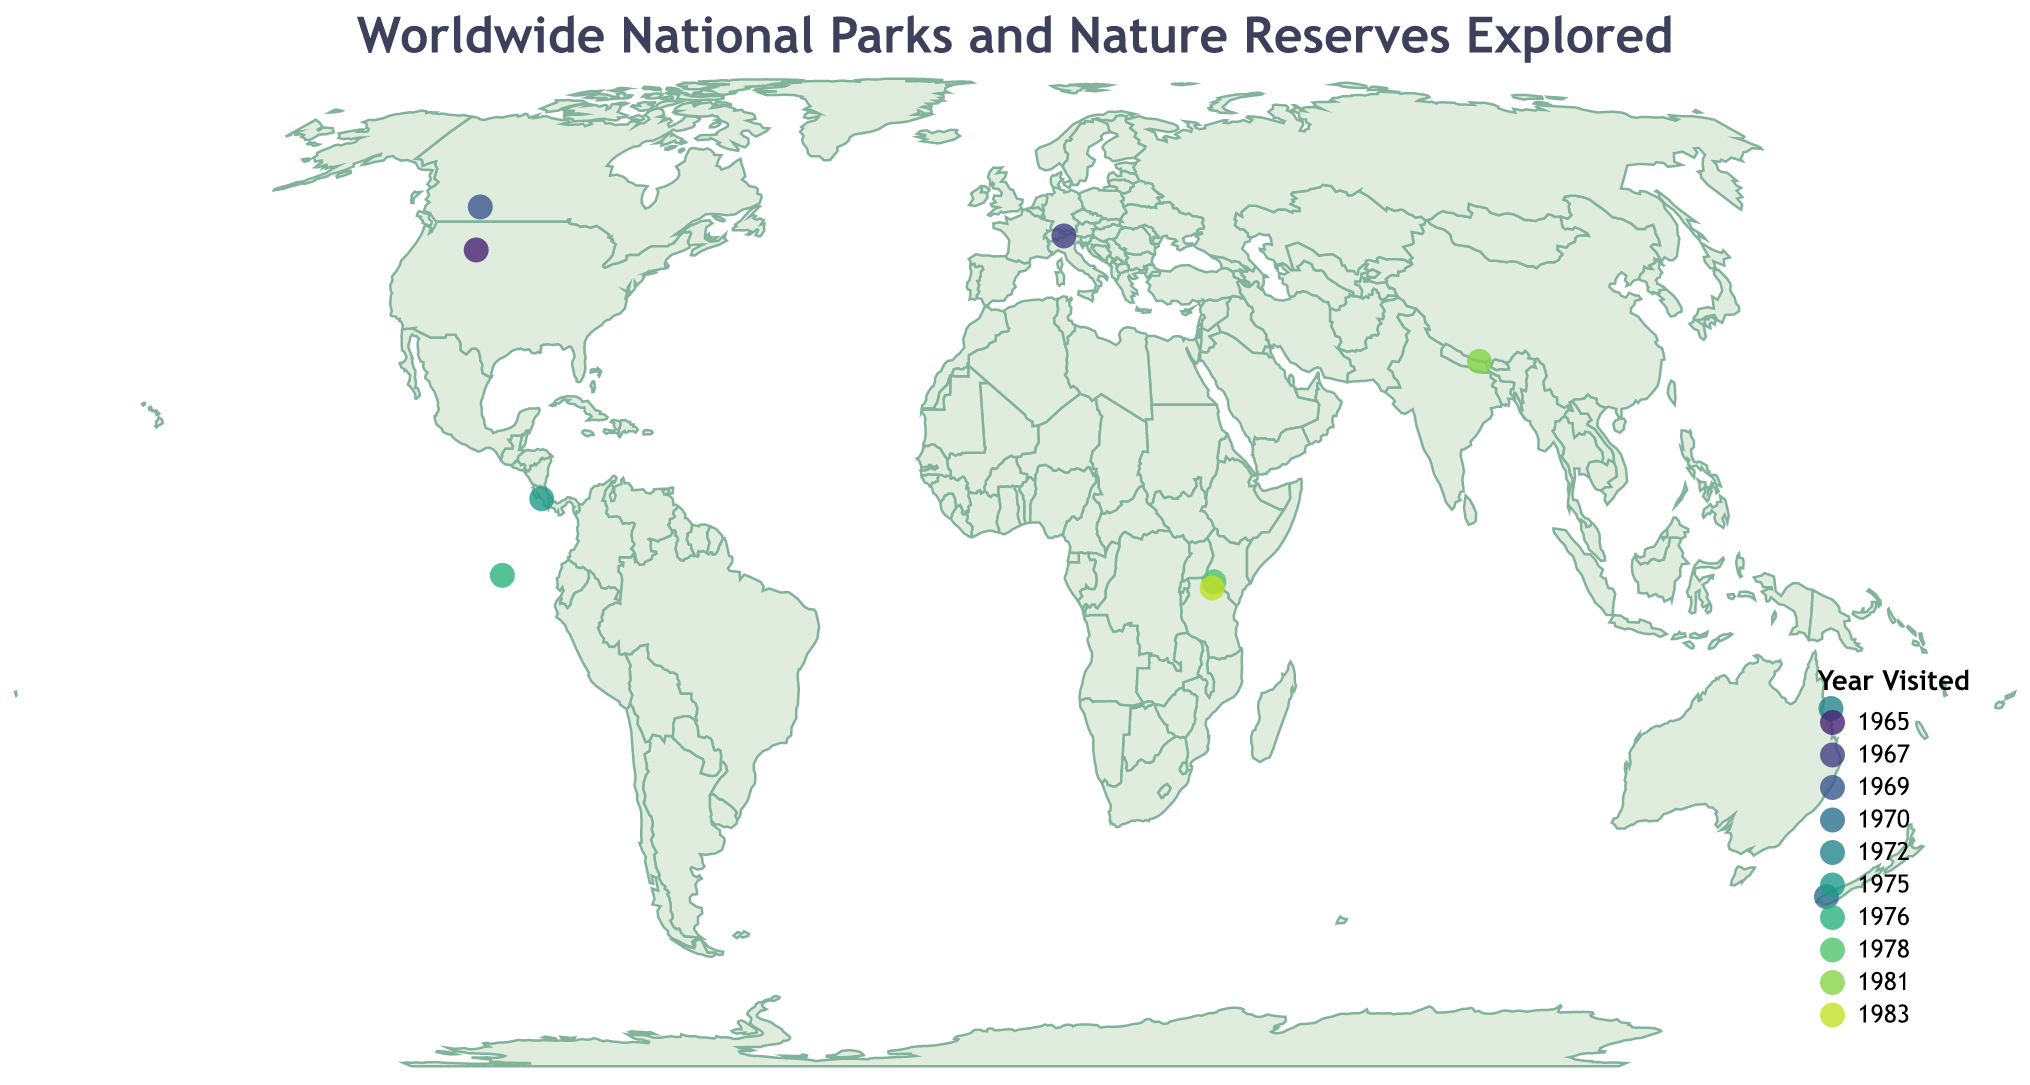What is the title of the figure? The title of the figure is usually placed at the top and provides a summary of what the figure illustrates. In this case, the title is "Worldwide National Parks and Nature Reserves Explored."
Answer: "Worldwide National Parks and Nature Reserves Explored" How many national parks or nature reserves are represented on the map? Each circle on the map represents a national park or nature reserve. By counting the circles, we can determine the number of locations. There are 10 circles representing 10 parks or reserves.
Answer: 10 Which country's park is represented by the northernmost circle on the map? To find the northernmost park, we look for the circle located furthest north on the map. The park in Canada, Banff National Park, is the northernmost.
Answer: Canada Which park was visited first according to the figure? To determine which park was visited first, we look at the legend "Year Visited" and find the earliest year. Yellowstone National Park in the United States was visited in 1965, the earliest in the dataset.
Answer: Yellowstone National Park Is the Serengeti National Park located east or west of the Masai Mara National Reserve? By comparing the longitudes of these two parks, we can determine their relative east-west positions. Serengeti National Park (Longitude: 34.8333) is slightly west of Masai Mara National Reserve (Longitude: 35.1245).
Answer: West How many parks were visited in the 1970s? We count the number of parks with a "Year Visited" within the range of 1970 to 1979. Three parks were visited in the 1970s: Great Barrier Reef Marine Park (1972), Manuel Antonio National Park (1975), and Galápagos National Park (1976).
Answer: 3 Which park is located closest to the equator? To determine the park closest to the equator, we look at the latitude values closest to zero. Masai Mara National Reserve in Kenya has a latitude of -1.5066, which is the closest to the equator.
Answer: Masai Mara National Reserve How many parks are located in the Southern Hemisphere? By examining the latitudes, we identify those with negative values, indicating the Southern Hemisphere. There are 5 parks: Great Barrier Reef Marine Park, Masai Mara National Reserve, Serengeti National Park, Fiordland National Park, and Galápagos National Park.
Answer: 5 Which park has the highest latitude? The park with the highest latitude (most positive value) can be identified by comparing all the latitude values. Banff National Park in Canada has the highest latitude at 51.4968.
Answer: Banff National Park 